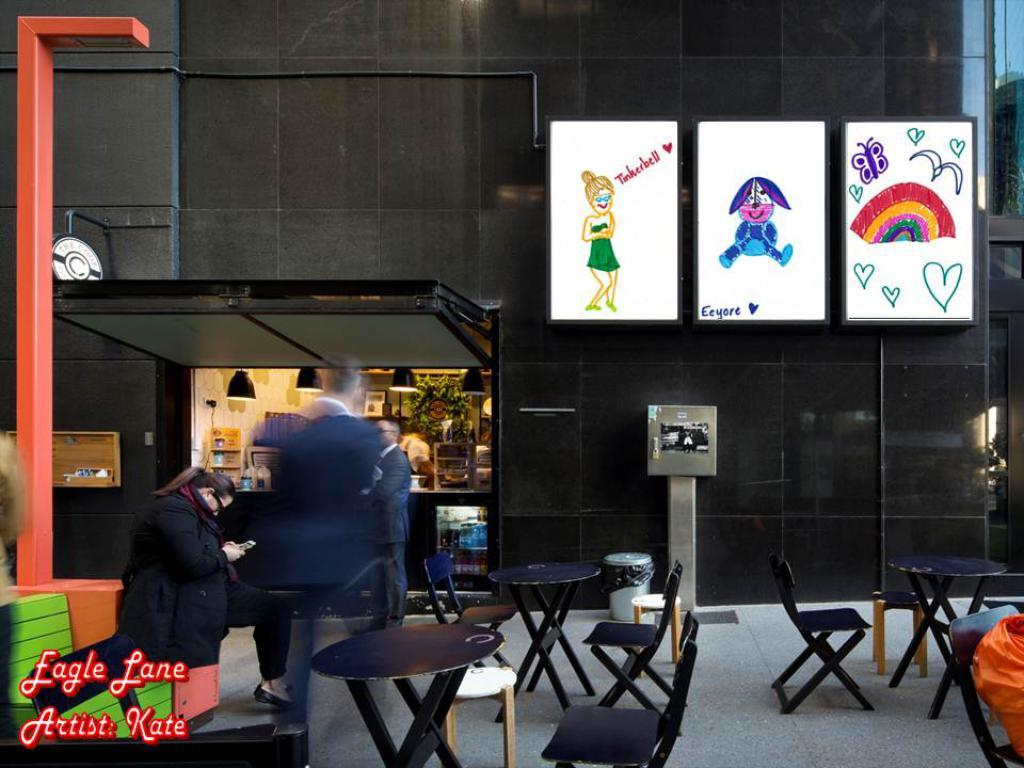Where was the image taken? The image was taken inside a mall. What type of furniture is visible in the image? There are chairs and tables in the image. What material is the floor made of? The floor is made of marble. How many posters are on the left side of the image? There are three posters on the left side of the image. What type of establishment can be seen in the image? There is a store in the image. What color is the marble floor? The marble floor is black in color. Can you see friends hanging out near the store in the image? There is no mention of friends in the image, so we cannot determine if they are present or not. 